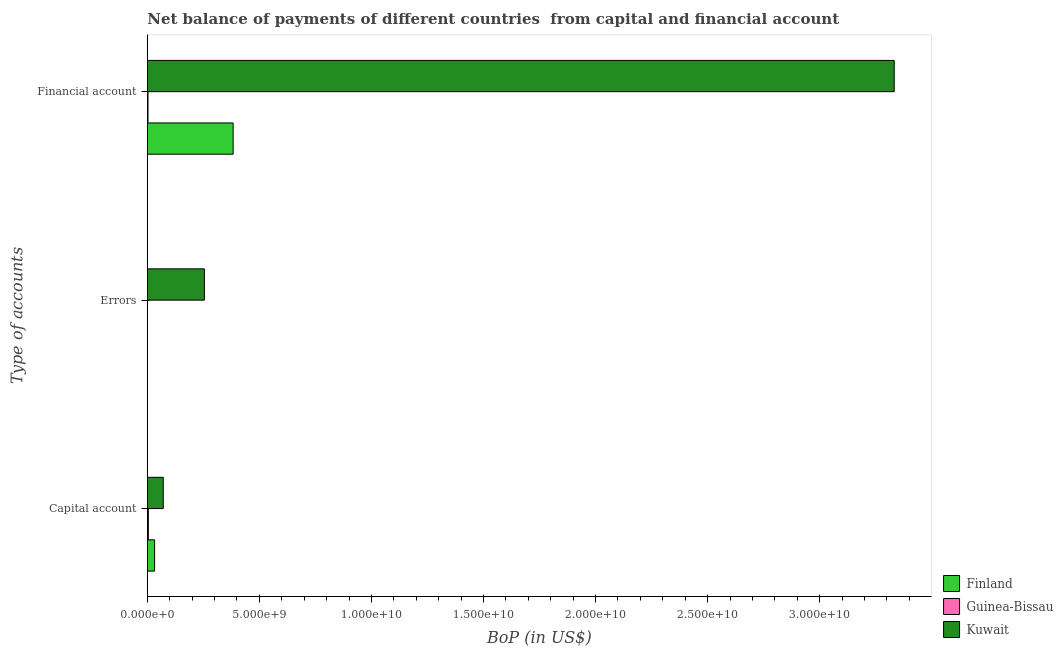Are the number of bars on each tick of the Y-axis equal?
Your answer should be very brief. No. How many bars are there on the 3rd tick from the top?
Keep it short and to the point. 3. How many bars are there on the 1st tick from the bottom?
Keep it short and to the point. 3. What is the label of the 3rd group of bars from the top?
Offer a very short reply. Capital account. Across all countries, what is the maximum amount of financial account?
Ensure brevity in your answer.  3.33e+1. Across all countries, what is the minimum amount of financial account?
Ensure brevity in your answer.  2.96e+07. In which country was the amount of net capital account maximum?
Offer a terse response. Kuwait. What is the total amount of errors in the graph?
Provide a short and direct response. 2.55e+09. What is the difference between the amount of net capital account in Finland and that in Guinea-Bissau?
Offer a very short reply. 2.78e+08. What is the difference between the amount of financial account in Finland and the amount of net capital account in Kuwait?
Make the answer very short. 3.12e+09. What is the average amount of net capital account per country?
Provide a short and direct response. 3.60e+08. What is the difference between the amount of net capital account and amount of financial account in Kuwait?
Keep it short and to the point. -3.26e+1. What is the ratio of the amount of net capital account in Guinea-Bissau to that in Finland?
Provide a short and direct response. 0.14. Is the amount of financial account in Finland less than that in Kuwait?
Provide a succinct answer. Yes. What is the difference between the highest and the second highest amount of financial account?
Your answer should be compact. 2.95e+1. What is the difference between the highest and the lowest amount of errors?
Offer a very short reply. 2.55e+09. Is it the case that in every country, the sum of the amount of net capital account and amount of errors is greater than the amount of financial account?
Your answer should be compact. No. How many countries are there in the graph?
Make the answer very short. 3. Are the values on the major ticks of X-axis written in scientific E-notation?
Make the answer very short. Yes. Does the graph contain any zero values?
Your answer should be very brief. Yes. Where does the legend appear in the graph?
Your answer should be very brief. Bottom right. How many legend labels are there?
Provide a succinct answer. 3. How are the legend labels stacked?
Keep it short and to the point. Vertical. What is the title of the graph?
Provide a short and direct response. Net balance of payments of different countries  from capital and financial account. Does "Djibouti" appear as one of the legend labels in the graph?
Your answer should be compact. No. What is the label or title of the X-axis?
Ensure brevity in your answer.  BoP (in US$). What is the label or title of the Y-axis?
Ensure brevity in your answer.  Type of accounts. What is the BoP (in US$) in Finland in Capital account?
Your response must be concise. 3.24e+08. What is the BoP (in US$) in Guinea-Bissau in Capital account?
Provide a short and direct response. 4.54e+07. What is the BoP (in US$) in Kuwait in Capital account?
Your response must be concise. 7.10e+08. What is the BoP (in US$) in Kuwait in Errors?
Keep it short and to the point. 2.55e+09. What is the BoP (in US$) of Finland in Financial account?
Make the answer very short. 3.83e+09. What is the BoP (in US$) of Guinea-Bissau in Financial account?
Your response must be concise. 2.96e+07. What is the BoP (in US$) of Kuwait in Financial account?
Provide a succinct answer. 3.33e+1. Across all Type of accounts, what is the maximum BoP (in US$) of Finland?
Keep it short and to the point. 3.83e+09. Across all Type of accounts, what is the maximum BoP (in US$) of Guinea-Bissau?
Offer a terse response. 4.54e+07. Across all Type of accounts, what is the maximum BoP (in US$) in Kuwait?
Give a very brief answer. 3.33e+1. Across all Type of accounts, what is the minimum BoP (in US$) in Kuwait?
Provide a short and direct response. 7.10e+08. What is the total BoP (in US$) in Finland in the graph?
Your answer should be very brief. 4.15e+09. What is the total BoP (in US$) of Guinea-Bissau in the graph?
Your response must be concise. 7.50e+07. What is the total BoP (in US$) of Kuwait in the graph?
Offer a terse response. 3.66e+1. What is the difference between the BoP (in US$) of Kuwait in Capital account and that in Errors?
Make the answer very short. -1.84e+09. What is the difference between the BoP (in US$) of Finland in Capital account and that in Financial account?
Provide a short and direct response. -3.51e+09. What is the difference between the BoP (in US$) of Guinea-Bissau in Capital account and that in Financial account?
Offer a terse response. 1.58e+07. What is the difference between the BoP (in US$) in Kuwait in Capital account and that in Financial account?
Offer a very short reply. -3.26e+1. What is the difference between the BoP (in US$) of Kuwait in Errors and that in Financial account?
Offer a very short reply. -3.08e+1. What is the difference between the BoP (in US$) of Finland in Capital account and the BoP (in US$) of Kuwait in Errors?
Provide a short and direct response. -2.22e+09. What is the difference between the BoP (in US$) in Guinea-Bissau in Capital account and the BoP (in US$) in Kuwait in Errors?
Ensure brevity in your answer.  -2.50e+09. What is the difference between the BoP (in US$) of Finland in Capital account and the BoP (in US$) of Guinea-Bissau in Financial account?
Give a very brief answer. 2.94e+08. What is the difference between the BoP (in US$) in Finland in Capital account and the BoP (in US$) in Kuwait in Financial account?
Make the answer very short. -3.30e+1. What is the difference between the BoP (in US$) of Guinea-Bissau in Capital account and the BoP (in US$) of Kuwait in Financial account?
Keep it short and to the point. -3.33e+1. What is the average BoP (in US$) of Finland per Type of accounts?
Offer a very short reply. 1.38e+09. What is the average BoP (in US$) of Guinea-Bissau per Type of accounts?
Offer a very short reply. 2.50e+07. What is the average BoP (in US$) of Kuwait per Type of accounts?
Offer a very short reply. 1.22e+1. What is the difference between the BoP (in US$) in Finland and BoP (in US$) in Guinea-Bissau in Capital account?
Offer a terse response. 2.78e+08. What is the difference between the BoP (in US$) of Finland and BoP (in US$) of Kuwait in Capital account?
Ensure brevity in your answer.  -3.86e+08. What is the difference between the BoP (in US$) of Guinea-Bissau and BoP (in US$) of Kuwait in Capital account?
Your answer should be very brief. -6.65e+08. What is the difference between the BoP (in US$) in Finland and BoP (in US$) in Guinea-Bissau in Financial account?
Provide a short and direct response. 3.80e+09. What is the difference between the BoP (in US$) in Finland and BoP (in US$) in Kuwait in Financial account?
Provide a succinct answer. -2.95e+1. What is the difference between the BoP (in US$) in Guinea-Bissau and BoP (in US$) in Kuwait in Financial account?
Give a very brief answer. -3.33e+1. What is the ratio of the BoP (in US$) of Kuwait in Capital account to that in Errors?
Keep it short and to the point. 0.28. What is the ratio of the BoP (in US$) in Finland in Capital account to that in Financial account?
Offer a terse response. 0.08. What is the ratio of the BoP (in US$) of Guinea-Bissau in Capital account to that in Financial account?
Your answer should be very brief. 1.53. What is the ratio of the BoP (in US$) of Kuwait in Capital account to that in Financial account?
Give a very brief answer. 0.02. What is the ratio of the BoP (in US$) in Kuwait in Errors to that in Financial account?
Make the answer very short. 0.08. What is the difference between the highest and the second highest BoP (in US$) in Kuwait?
Offer a very short reply. 3.08e+1. What is the difference between the highest and the lowest BoP (in US$) of Finland?
Your response must be concise. 3.83e+09. What is the difference between the highest and the lowest BoP (in US$) of Guinea-Bissau?
Your answer should be compact. 4.54e+07. What is the difference between the highest and the lowest BoP (in US$) in Kuwait?
Your answer should be compact. 3.26e+1. 